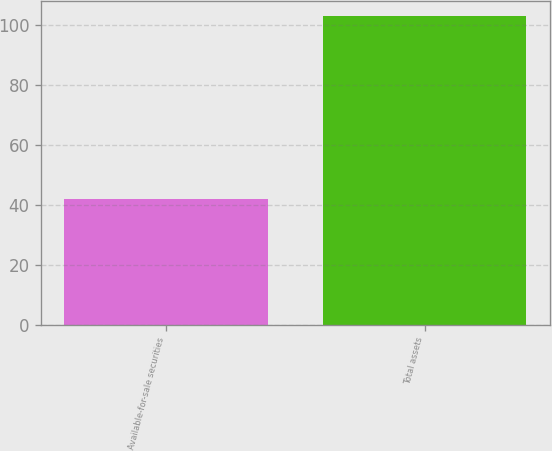Convert chart to OTSL. <chart><loc_0><loc_0><loc_500><loc_500><bar_chart><fcel>Available-for-sale securities<fcel>Total assets<nl><fcel>42<fcel>103<nl></chart> 